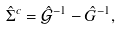Convert formula to latex. <formula><loc_0><loc_0><loc_500><loc_500>\hat { \Sigma } ^ { c } = \hat { \mathcal { G } } ^ { - 1 } - \hat { G } ^ { - 1 } ,</formula> 